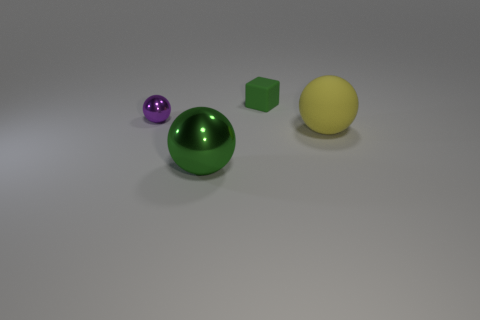What material is the big ball right of the green thing that is behind the metal object in front of the small purple shiny ball made of?
Keep it short and to the point. Rubber. There is a big metallic sphere; does it have the same color as the small thing that is behind the purple object?
Give a very brief answer. Yes. Is there anything else that is the same shape as the yellow rubber thing?
Provide a short and direct response. Yes. There is a tiny thing that is behind the metallic thing that is left of the green shiny ball; what is its color?
Your response must be concise. Green. What number of green blocks are there?
Keep it short and to the point. 1. What number of matte things are either cubes or green balls?
Give a very brief answer. 1. How many large spheres have the same color as the small cube?
Your answer should be very brief. 1. There is a big thing to the left of the yellow object in front of the tiny block; what is it made of?
Provide a short and direct response. Metal. The green rubber object has what size?
Offer a very short reply. Small. How many metal spheres are the same size as the rubber block?
Provide a succinct answer. 1. 